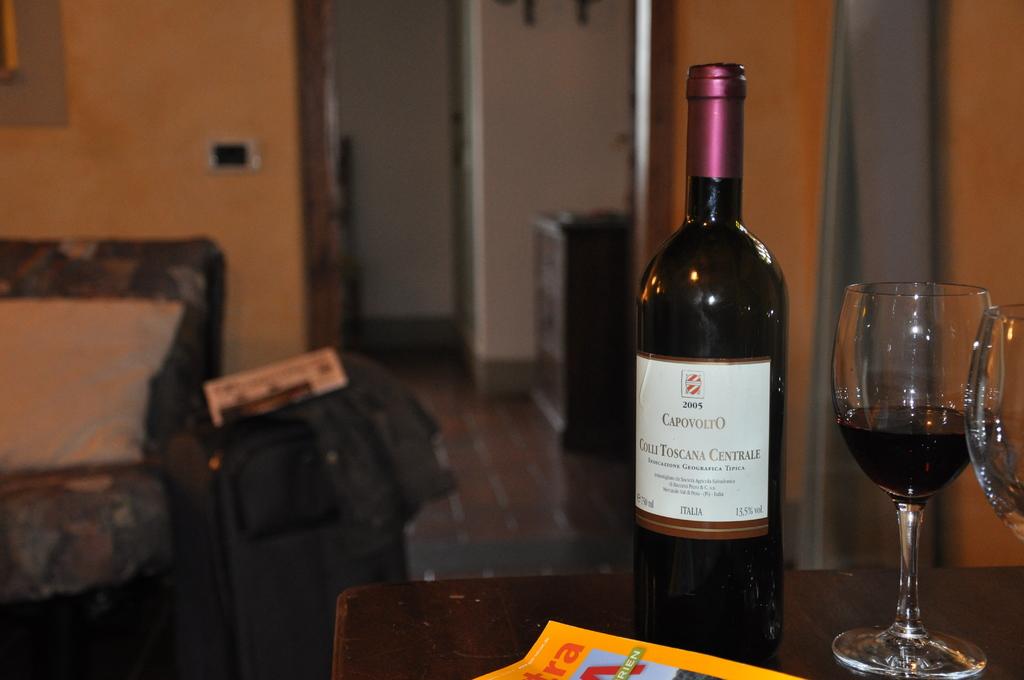What year was the wine made?
Your answer should be compact. 2005. What brand of wine?
Your answer should be very brief. Capovolto. 